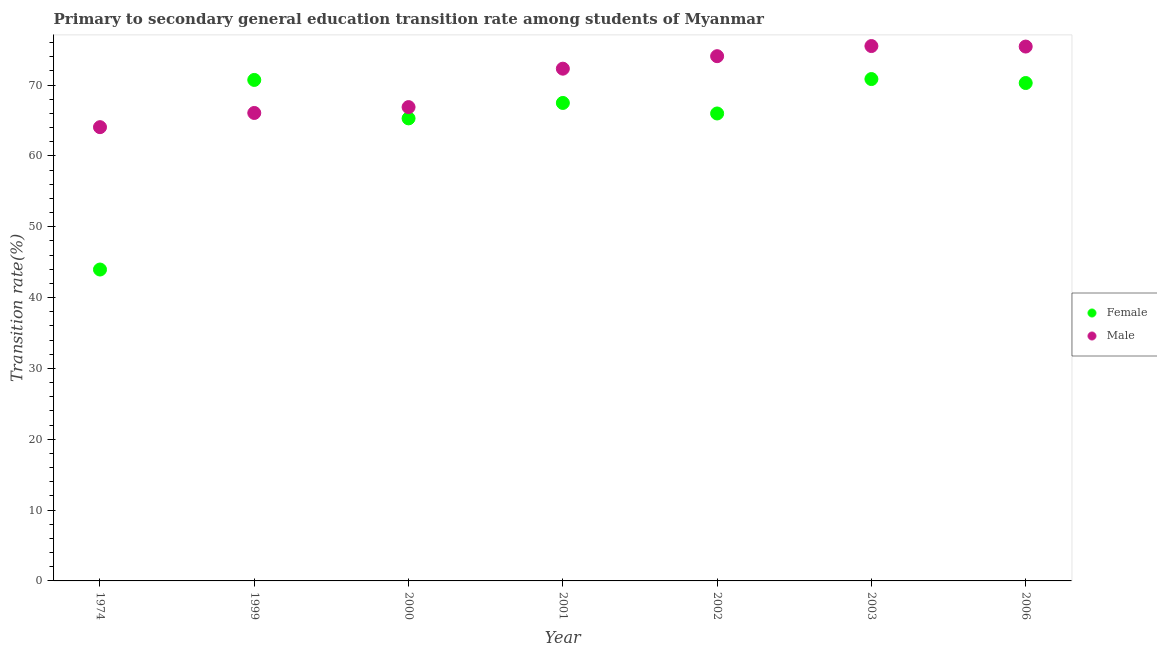What is the transition rate among female students in 2002?
Offer a terse response. 66. Across all years, what is the maximum transition rate among male students?
Provide a succinct answer. 75.52. Across all years, what is the minimum transition rate among male students?
Offer a very short reply. 64.07. In which year was the transition rate among male students maximum?
Make the answer very short. 2003. In which year was the transition rate among female students minimum?
Keep it short and to the point. 1974. What is the total transition rate among male students in the graph?
Give a very brief answer. 494.44. What is the difference between the transition rate among female students in 1999 and that in 2002?
Your answer should be compact. 4.74. What is the difference between the transition rate among female students in 2002 and the transition rate among male students in 2000?
Provide a short and direct response. -0.9. What is the average transition rate among female students per year?
Keep it short and to the point. 64.95. In the year 2000, what is the difference between the transition rate among female students and transition rate among male students?
Provide a short and direct response. -1.59. What is the ratio of the transition rate among female students in 1974 to that in 2002?
Provide a short and direct response. 0.67. Is the transition rate among male students in 1999 less than that in 2001?
Your answer should be compact. Yes. Is the difference between the transition rate among female students in 2000 and 2002 greater than the difference between the transition rate among male students in 2000 and 2002?
Provide a short and direct response. Yes. What is the difference between the highest and the second highest transition rate among male students?
Your answer should be compact. 0.07. What is the difference between the highest and the lowest transition rate among male students?
Your answer should be very brief. 11.45. In how many years, is the transition rate among female students greater than the average transition rate among female students taken over all years?
Your response must be concise. 6. Is the sum of the transition rate among female students in 1999 and 2001 greater than the maximum transition rate among male students across all years?
Ensure brevity in your answer.  Yes. Does the transition rate among female students monotonically increase over the years?
Ensure brevity in your answer.  No. How many years are there in the graph?
Your response must be concise. 7. Are the values on the major ticks of Y-axis written in scientific E-notation?
Ensure brevity in your answer.  No. Does the graph contain any zero values?
Provide a succinct answer. No. Where does the legend appear in the graph?
Offer a very short reply. Center right. What is the title of the graph?
Your answer should be compact. Primary to secondary general education transition rate among students of Myanmar. What is the label or title of the Y-axis?
Provide a short and direct response. Transition rate(%). What is the Transition rate(%) in Female in 1974?
Your answer should be compact. 43.97. What is the Transition rate(%) of Male in 1974?
Your response must be concise. 64.07. What is the Transition rate(%) in Female in 1999?
Offer a very short reply. 70.74. What is the Transition rate(%) of Male in 1999?
Your answer should be compact. 66.07. What is the Transition rate(%) in Female in 2000?
Provide a succinct answer. 65.31. What is the Transition rate(%) in Male in 2000?
Your answer should be very brief. 66.9. What is the Transition rate(%) of Female in 2001?
Provide a succinct answer. 67.49. What is the Transition rate(%) in Male in 2001?
Provide a short and direct response. 72.33. What is the Transition rate(%) of Female in 2002?
Give a very brief answer. 66. What is the Transition rate(%) in Male in 2002?
Your answer should be compact. 74.09. What is the Transition rate(%) of Female in 2003?
Make the answer very short. 70.86. What is the Transition rate(%) of Male in 2003?
Provide a succinct answer. 75.52. What is the Transition rate(%) in Female in 2006?
Keep it short and to the point. 70.3. What is the Transition rate(%) in Male in 2006?
Your answer should be compact. 75.45. Across all years, what is the maximum Transition rate(%) in Female?
Make the answer very short. 70.86. Across all years, what is the maximum Transition rate(%) of Male?
Keep it short and to the point. 75.52. Across all years, what is the minimum Transition rate(%) of Female?
Your response must be concise. 43.97. Across all years, what is the minimum Transition rate(%) of Male?
Make the answer very short. 64.07. What is the total Transition rate(%) of Female in the graph?
Make the answer very short. 454.67. What is the total Transition rate(%) of Male in the graph?
Your response must be concise. 494.44. What is the difference between the Transition rate(%) in Female in 1974 and that in 1999?
Give a very brief answer. -26.77. What is the difference between the Transition rate(%) of Male in 1974 and that in 1999?
Provide a short and direct response. -2. What is the difference between the Transition rate(%) of Female in 1974 and that in 2000?
Provide a succinct answer. -21.34. What is the difference between the Transition rate(%) in Male in 1974 and that in 2000?
Ensure brevity in your answer.  -2.83. What is the difference between the Transition rate(%) of Female in 1974 and that in 2001?
Offer a terse response. -23.52. What is the difference between the Transition rate(%) in Male in 1974 and that in 2001?
Your answer should be very brief. -8.26. What is the difference between the Transition rate(%) of Female in 1974 and that in 2002?
Provide a succinct answer. -22.03. What is the difference between the Transition rate(%) in Male in 1974 and that in 2002?
Your answer should be compact. -10.02. What is the difference between the Transition rate(%) of Female in 1974 and that in 2003?
Your answer should be compact. -26.9. What is the difference between the Transition rate(%) in Male in 1974 and that in 2003?
Make the answer very short. -11.45. What is the difference between the Transition rate(%) in Female in 1974 and that in 2006?
Provide a short and direct response. -26.34. What is the difference between the Transition rate(%) of Male in 1974 and that in 2006?
Your answer should be compact. -11.38. What is the difference between the Transition rate(%) in Female in 1999 and that in 2000?
Keep it short and to the point. 5.43. What is the difference between the Transition rate(%) in Male in 1999 and that in 2000?
Keep it short and to the point. -0.83. What is the difference between the Transition rate(%) in Female in 1999 and that in 2001?
Ensure brevity in your answer.  3.25. What is the difference between the Transition rate(%) in Male in 1999 and that in 2001?
Your response must be concise. -6.25. What is the difference between the Transition rate(%) of Female in 1999 and that in 2002?
Keep it short and to the point. 4.74. What is the difference between the Transition rate(%) of Male in 1999 and that in 2002?
Your answer should be very brief. -8.02. What is the difference between the Transition rate(%) in Female in 1999 and that in 2003?
Make the answer very short. -0.12. What is the difference between the Transition rate(%) of Male in 1999 and that in 2003?
Your answer should be compact. -9.45. What is the difference between the Transition rate(%) of Female in 1999 and that in 2006?
Give a very brief answer. 0.44. What is the difference between the Transition rate(%) of Male in 1999 and that in 2006?
Offer a terse response. -9.38. What is the difference between the Transition rate(%) in Female in 2000 and that in 2001?
Offer a very short reply. -2.18. What is the difference between the Transition rate(%) of Male in 2000 and that in 2001?
Offer a very short reply. -5.43. What is the difference between the Transition rate(%) of Female in 2000 and that in 2002?
Your response must be concise. -0.69. What is the difference between the Transition rate(%) in Male in 2000 and that in 2002?
Offer a terse response. -7.19. What is the difference between the Transition rate(%) of Female in 2000 and that in 2003?
Your answer should be very brief. -5.55. What is the difference between the Transition rate(%) in Male in 2000 and that in 2003?
Give a very brief answer. -8.62. What is the difference between the Transition rate(%) of Female in 2000 and that in 2006?
Your answer should be very brief. -4.99. What is the difference between the Transition rate(%) of Male in 2000 and that in 2006?
Give a very brief answer. -8.55. What is the difference between the Transition rate(%) of Female in 2001 and that in 2002?
Your answer should be compact. 1.49. What is the difference between the Transition rate(%) of Male in 2001 and that in 2002?
Your answer should be compact. -1.76. What is the difference between the Transition rate(%) of Female in 2001 and that in 2003?
Offer a very short reply. -3.37. What is the difference between the Transition rate(%) of Male in 2001 and that in 2003?
Offer a terse response. -3.19. What is the difference between the Transition rate(%) of Female in 2001 and that in 2006?
Offer a very short reply. -2.81. What is the difference between the Transition rate(%) of Male in 2001 and that in 2006?
Keep it short and to the point. -3.12. What is the difference between the Transition rate(%) in Female in 2002 and that in 2003?
Your answer should be compact. -4.86. What is the difference between the Transition rate(%) of Male in 2002 and that in 2003?
Offer a very short reply. -1.43. What is the difference between the Transition rate(%) in Female in 2002 and that in 2006?
Keep it short and to the point. -4.3. What is the difference between the Transition rate(%) of Male in 2002 and that in 2006?
Provide a short and direct response. -1.36. What is the difference between the Transition rate(%) of Female in 2003 and that in 2006?
Your answer should be very brief. 0.56. What is the difference between the Transition rate(%) in Male in 2003 and that in 2006?
Offer a terse response. 0.07. What is the difference between the Transition rate(%) of Female in 1974 and the Transition rate(%) of Male in 1999?
Keep it short and to the point. -22.11. What is the difference between the Transition rate(%) in Female in 1974 and the Transition rate(%) in Male in 2000?
Your response must be concise. -22.93. What is the difference between the Transition rate(%) in Female in 1974 and the Transition rate(%) in Male in 2001?
Give a very brief answer. -28.36. What is the difference between the Transition rate(%) of Female in 1974 and the Transition rate(%) of Male in 2002?
Offer a terse response. -30.12. What is the difference between the Transition rate(%) in Female in 1974 and the Transition rate(%) in Male in 2003?
Your answer should be compact. -31.55. What is the difference between the Transition rate(%) in Female in 1974 and the Transition rate(%) in Male in 2006?
Your response must be concise. -31.48. What is the difference between the Transition rate(%) in Female in 1999 and the Transition rate(%) in Male in 2000?
Ensure brevity in your answer.  3.84. What is the difference between the Transition rate(%) in Female in 1999 and the Transition rate(%) in Male in 2001?
Give a very brief answer. -1.59. What is the difference between the Transition rate(%) in Female in 1999 and the Transition rate(%) in Male in 2002?
Ensure brevity in your answer.  -3.35. What is the difference between the Transition rate(%) in Female in 1999 and the Transition rate(%) in Male in 2003?
Your answer should be very brief. -4.78. What is the difference between the Transition rate(%) of Female in 1999 and the Transition rate(%) of Male in 2006?
Your answer should be compact. -4.71. What is the difference between the Transition rate(%) of Female in 2000 and the Transition rate(%) of Male in 2001?
Give a very brief answer. -7.02. What is the difference between the Transition rate(%) in Female in 2000 and the Transition rate(%) in Male in 2002?
Ensure brevity in your answer.  -8.78. What is the difference between the Transition rate(%) in Female in 2000 and the Transition rate(%) in Male in 2003?
Make the answer very short. -10.21. What is the difference between the Transition rate(%) of Female in 2000 and the Transition rate(%) of Male in 2006?
Give a very brief answer. -10.14. What is the difference between the Transition rate(%) in Female in 2001 and the Transition rate(%) in Male in 2002?
Provide a short and direct response. -6.6. What is the difference between the Transition rate(%) in Female in 2001 and the Transition rate(%) in Male in 2003?
Provide a succinct answer. -8.03. What is the difference between the Transition rate(%) of Female in 2001 and the Transition rate(%) of Male in 2006?
Ensure brevity in your answer.  -7.96. What is the difference between the Transition rate(%) in Female in 2002 and the Transition rate(%) in Male in 2003?
Ensure brevity in your answer.  -9.52. What is the difference between the Transition rate(%) in Female in 2002 and the Transition rate(%) in Male in 2006?
Your answer should be compact. -9.45. What is the difference between the Transition rate(%) in Female in 2003 and the Transition rate(%) in Male in 2006?
Your answer should be very brief. -4.59. What is the average Transition rate(%) of Female per year?
Your answer should be compact. 64.95. What is the average Transition rate(%) of Male per year?
Give a very brief answer. 70.63. In the year 1974, what is the difference between the Transition rate(%) of Female and Transition rate(%) of Male?
Offer a terse response. -20.1. In the year 1999, what is the difference between the Transition rate(%) in Female and Transition rate(%) in Male?
Your response must be concise. 4.66. In the year 2000, what is the difference between the Transition rate(%) of Female and Transition rate(%) of Male?
Your answer should be very brief. -1.59. In the year 2001, what is the difference between the Transition rate(%) of Female and Transition rate(%) of Male?
Offer a terse response. -4.84. In the year 2002, what is the difference between the Transition rate(%) of Female and Transition rate(%) of Male?
Your answer should be very brief. -8.09. In the year 2003, what is the difference between the Transition rate(%) of Female and Transition rate(%) of Male?
Offer a terse response. -4.66. In the year 2006, what is the difference between the Transition rate(%) of Female and Transition rate(%) of Male?
Offer a very short reply. -5.15. What is the ratio of the Transition rate(%) of Female in 1974 to that in 1999?
Your answer should be very brief. 0.62. What is the ratio of the Transition rate(%) of Male in 1974 to that in 1999?
Your answer should be compact. 0.97. What is the ratio of the Transition rate(%) in Female in 1974 to that in 2000?
Your answer should be compact. 0.67. What is the ratio of the Transition rate(%) in Male in 1974 to that in 2000?
Your response must be concise. 0.96. What is the ratio of the Transition rate(%) of Female in 1974 to that in 2001?
Your response must be concise. 0.65. What is the ratio of the Transition rate(%) of Male in 1974 to that in 2001?
Provide a succinct answer. 0.89. What is the ratio of the Transition rate(%) of Female in 1974 to that in 2002?
Give a very brief answer. 0.67. What is the ratio of the Transition rate(%) of Male in 1974 to that in 2002?
Your answer should be very brief. 0.86. What is the ratio of the Transition rate(%) in Female in 1974 to that in 2003?
Make the answer very short. 0.62. What is the ratio of the Transition rate(%) in Male in 1974 to that in 2003?
Make the answer very short. 0.85. What is the ratio of the Transition rate(%) in Female in 1974 to that in 2006?
Your answer should be very brief. 0.63. What is the ratio of the Transition rate(%) in Male in 1974 to that in 2006?
Give a very brief answer. 0.85. What is the ratio of the Transition rate(%) in Female in 1999 to that in 2000?
Offer a very short reply. 1.08. What is the ratio of the Transition rate(%) of Male in 1999 to that in 2000?
Ensure brevity in your answer.  0.99. What is the ratio of the Transition rate(%) of Female in 1999 to that in 2001?
Keep it short and to the point. 1.05. What is the ratio of the Transition rate(%) in Male in 1999 to that in 2001?
Offer a very short reply. 0.91. What is the ratio of the Transition rate(%) of Female in 1999 to that in 2002?
Offer a terse response. 1.07. What is the ratio of the Transition rate(%) in Male in 1999 to that in 2002?
Your response must be concise. 0.89. What is the ratio of the Transition rate(%) of Male in 1999 to that in 2003?
Your answer should be compact. 0.87. What is the ratio of the Transition rate(%) in Male in 1999 to that in 2006?
Make the answer very short. 0.88. What is the ratio of the Transition rate(%) of Male in 2000 to that in 2001?
Keep it short and to the point. 0.93. What is the ratio of the Transition rate(%) in Male in 2000 to that in 2002?
Make the answer very short. 0.9. What is the ratio of the Transition rate(%) in Female in 2000 to that in 2003?
Your answer should be compact. 0.92. What is the ratio of the Transition rate(%) of Male in 2000 to that in 2003?
Provide a short and direct response. 0.89. What is the ratio of the Transition rate(%) of Female in 2000 to that in 2006?
Your response must be concise. 0.93. What is the ratio of the Transition rate(%) of Male in 2000 to that in 2006?
Provide a succinct answer. 0.89. What is the ratio of the Transition rate(%) in Female in 2001 to that in 2002?
Provide a short and direct response. 1.02. What is the ratio of the Transition rate(%) of Male in 2001 to that in 2002?
Provide a short and direct response. 0.98. What is the ratio of the Transition rate(%) of Female in 2001 to that in 2003?
Keep it short and to the point. 0.95. What is the ratio of the Transition rate(%) of Male in 2001 to that in 2003?
Make the answer very short. 0.96. What is the ratio of the Transition rate(%) in Male in 2001 to that in 2006?
Your answer should be compact. 0.96. What is the ratio of the Transition rate(%) of Female in 2002 to that in 2003?
Offer a very short reply. 0.93. What is the ratio of the Transition rate(%) of Male in 2002 to that in 2003?
Give a very brief answer. 0.98. What is the ratio of the Transition rate(%) of Female in 2002 to that in 2006?
Your answer should be compact. 0.94. What is the ratio of the Transition rate(%) of Male in 2002 to that in 2006?
Your response must be concise. 0.98. What is the ratio of the Transition rate(%) in Male in 2003 to that in 2006?
Your response must be concise. 1. What is the difference between the highest and the second highest Transition rate(%) in Female?
Provide a succinct answer. 0.12. What is the difference between the highest and the second highest Transition rate(%) in Male?
Offer a terse response. 0.07. What is the difference between the highest and the lowest Transition rate(%) in Female?
Your response must be concise. 26.9. What is the difference between the highest and the lowest Transition rate(%) in Male?
Offer a very short reply. 11.45. 